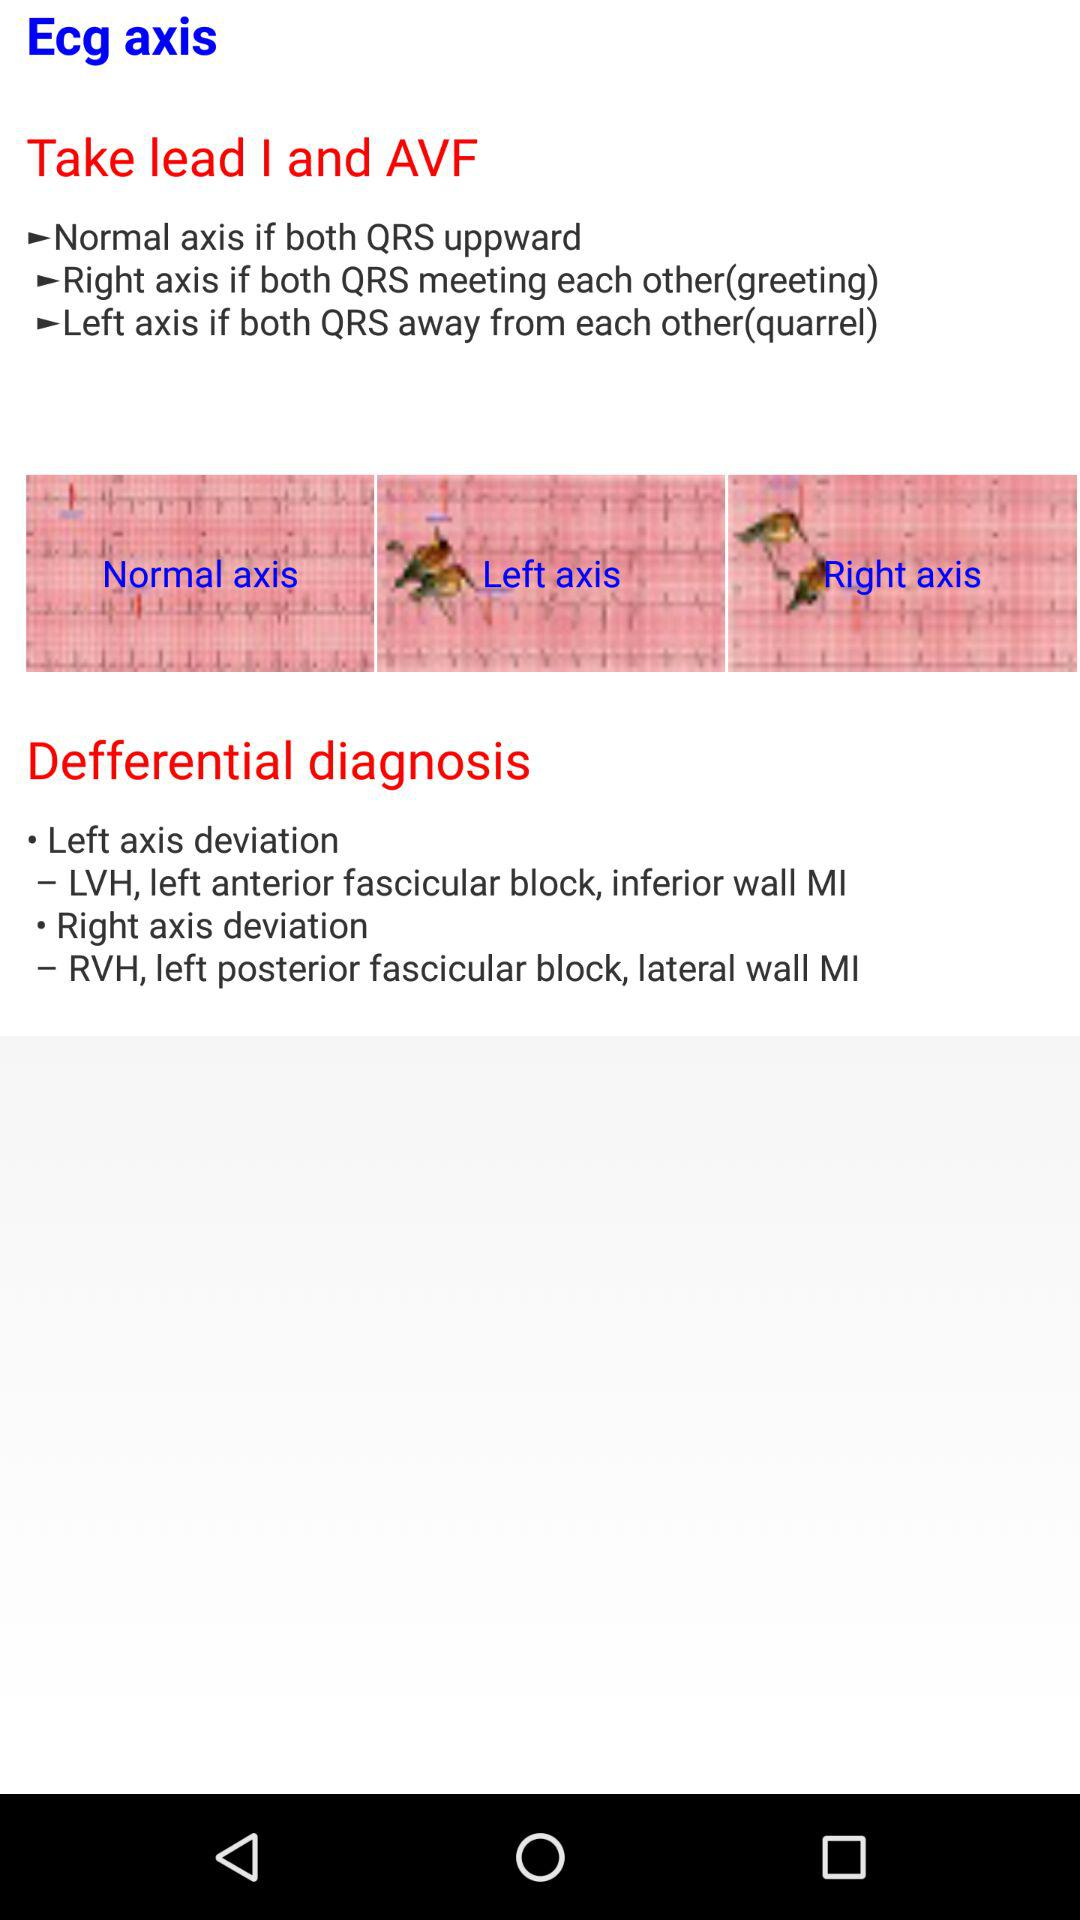How many different axis are mentioned in the text?
Answer the question using a single word or phrase. 3 